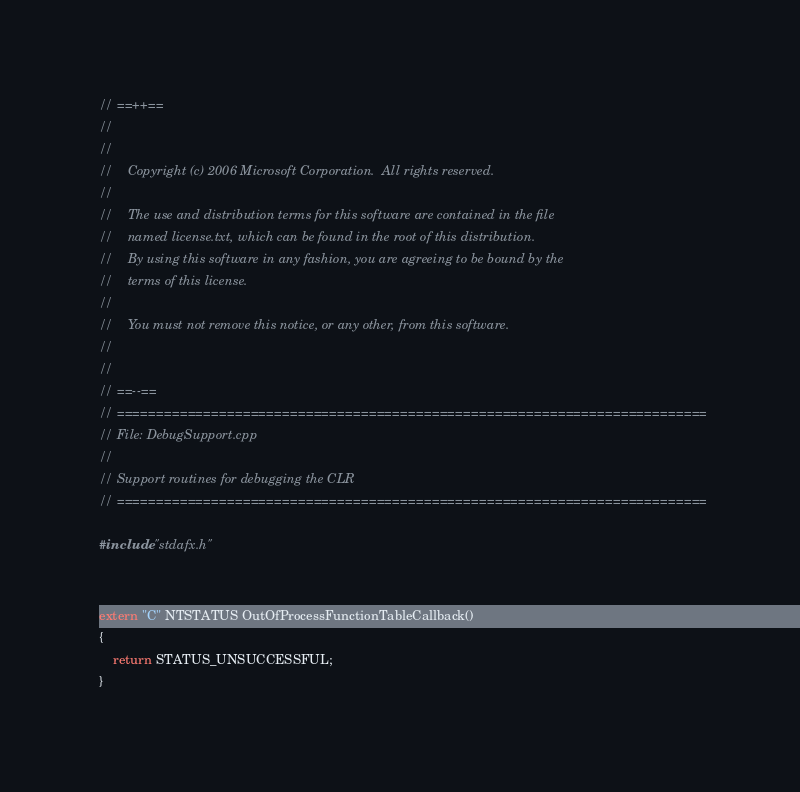<code> <loc_0><loc_0><loc_500><loc_500><_C++_>// ==++==
//
//   
//    Copyright (c) 2006 Microsoft Corporation.  All rights reserved.
//   
//    The use and distribution terms for this software are contained in the file
//    named license.txt, which can be found in the root of this distribution.
//    By using this software in any fashion, you are agreeing to be bound by the
//    terms of this license.
//   
//    You must not remove this notice, or any other, from this software.
//   
//
// ==--==
// ===========================================================================
// File: DebugSupport.cpp
//
// Support routines for debugging the CLR
// ===========================================================================

#include "stdafx.h"


extern "C" NTSTATUS OutOfProcessFunctionTableCallback()
{
    return STATUS_UNSUCCESSFUL;
}



</code> 